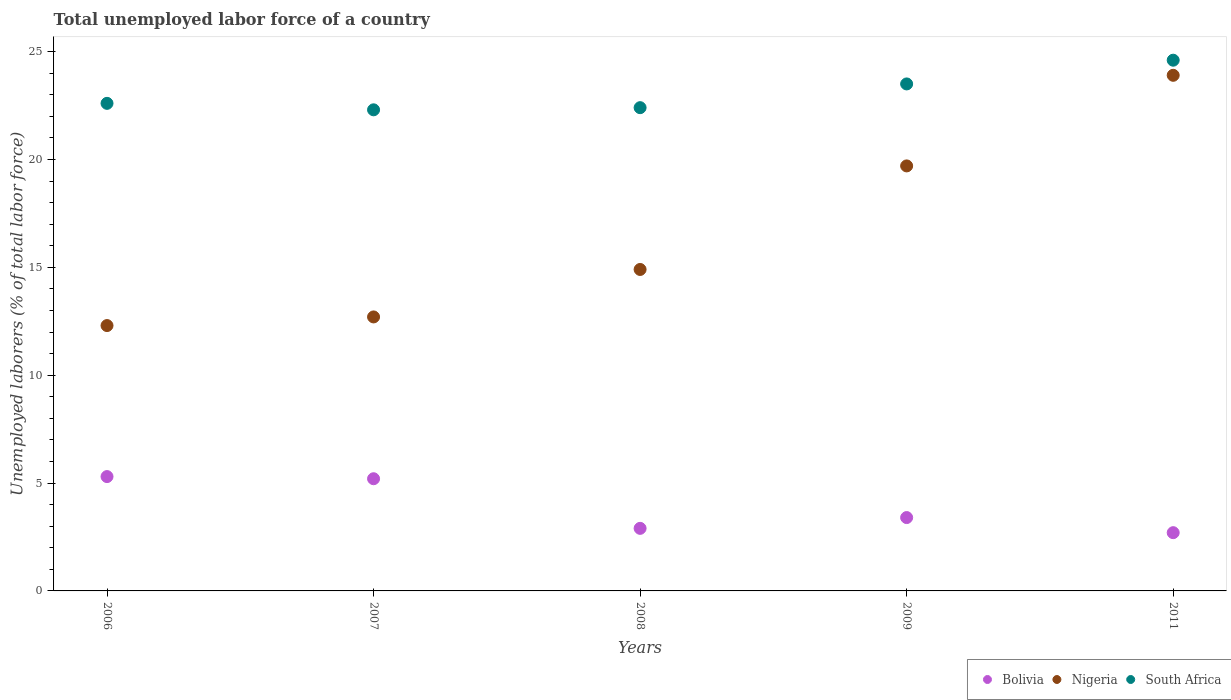What is the total unemployed labor force in Nigeria in 2009?
Offer a terse response. 19.7. Across all years, what is the maximum total unemployed labor force in South Africa?
Offer a very short reply. 24.6. Across all years, what is the minimum total unemployed labor force in Bolivia?
Provide a succinct answer. 2.7. In which year was the total unemployed labor force in Nigeria minimum?
Provide a short and direct response. 2006. What is the total total unemployed labor force in Bolivia in the graph?
Keep it short and to the point. 19.5. What is the difference between the total unemployed labor force in Nigeria in 2007 and that in 2008?
Give a very brief answer. -2.2. What is the difference between the total unemployed labor force in Bolivia in 2008 and the total unemployed labor force in Nigeria in 2009?
Your response must be concise. -16.8. What is the average total unemployed labor force in Nigeria per year?
Give a very brief answer. 16.7. In the year 2011, what is the difference between the total unemployed labor force in South Africa and total unemployed labor force in Nigeria?
Your answer should be compact. 0.7. In how many years, is the total unemployed labor force in Nigeria greater than 7 %?
Keep it short and to the point. 5. What is the ratio of the total unemployed labor force in Nigeria in 2008 to that in 2011?
Offer a very short reply. 0.62. Is the total unemployed labor force in Bolivia in 2006 less than that in 2007?
Your answer should be very brief. No. Is the difference between the total unemployed labor force in South Africa in 2007 and 2008 greater than the difference between the total unemployed labor force in Nigeria in 2007 and 2008?
Give a very brief answer. Yes. What is the difference between the highest and the second highest total unemployed labor force in South Africa?
Keep it short and to the point. 1.1. What is the difference between the highest and the lowest total unemployed labor force in Bolivia?
Keep it short and to the point. 2.6. Is the sum of the total unemployed labor force in South Africa in 2007 and 2011 greater than the maximum total unemployed labor force in Bolivia across all years?
Give a very brief answer. Yes. Does the total unemployed labor force in South Africa monotonically increase over the years?
Give a very brief answer. No. How many years are there in the graph?
Give a very brief answer. 5. What is the difference between two consecutive major ticks on the Y-axis?
Offer a very short reply. 5. Are the values on the major ticks of Y-axis written in scientific E-notation?
Offer a terse response. No. Does the graph contain grids?
Your response must be concise. No. Where does the legend appear in the graph?
Provide a succinct answer. Bottom right. What is the title of the graph?
Keep it short and to the point. Total unemployed labor force of a country. Does "Jamaica" appear as one of the legend labels in the graph?
Your response must be concise. No. What is the label or title of the X-axis?
Give a very brief answer. Years. What is the label or title of the Y-axis?
Provide a succinct answer. Unemployed laborers (% of total labor force). What is the Unemployed laborers (% of total labor force) of Bolivia in 2006?
Make the answer very short. 5.3. What is the Unemployed laborers (% of total labor force) in Nigeria in 2006?
Keep it short and to the point. 12.3. What is the Unemployed laborers (% of total labor force) of South Africa in 2006?
Offer a terse response. 22.6. What is the Unemployed laborers (% of total labor force) in Bolivia in 2007?
Offer a very short reply. 5.2. What is the Unemployed laborers (% of total labor force) in Nigeria in 2007?
Make the answer very short. 12.7. What is the Unemployed laborers (% of total labor force) of South Africa in 2007?
Make the answer very short. 22.3. What is the Unemployed laborers (% of total labor force) in Bolivia in 2008?
Make the answer very short. 2.9. What is the Unemployed laborers (% of total labor force) in Nigeria in 2008?
Your answer should be compact. 14.9. What is the Unemployed laborers (% of total labor force) in South Africa in 2008?
Make the answer very short. 22.4. What is the Unemployed laborers (% of total labor force) of Bolivia in 2009?
Keep it short and to the point. 3.4. What is the Unemployed laborers (% of total labor force) of Nigeria in 2009?
Keep it short and to the point. 19.7. What is the Unemployed laborers (% of total labor force) in South Africa in 2009?
Give a very brief answer. 23.5. What is the Unemployed laborers (% of total labor force) of Bolivia in 2011?
Offer a terse response. 2.7. What is the Unemployed laborers (% of total labor force) in Nigeria in 2011?
Give a very brief answer. 23.9. What is the Unemployed laborers (% of total labor force) in South Africa in 2011?
Your response must be concise. 24.6. Across all years, what is the maximum Unemployed laborers (% of total labor force) of Bolivia?
Offer a very short reply. 5.3. Across all years, what is the maximum Unemployed laborers (% of total labor force) of Nigeria?
Keep it short and to the point. 23.9. Across all years, what is the maximum Unemployed laborers (% of total labor force) of South Africa?
Keep it short and to the point. 24.6. Across all years, what is the minimum Unemployed laborers (% of total labor force) of Bolivia?
Provide a short and direct response. 2.7. Across all years, what is the minimum Unemployed laborers (% of total labor force) of Nigeria?
Keep it short and to the point. 12.3. Across all years, what is the minimum Unemployed laborers (% of total labor force) in South Africa?
Your answer should be compact. 22.3. What is the total Unemployed laborers (% of total labor force) of Bolivia in the graph?
Offer a terse response. 19.5. What is the total Unemployed laborers (% of total labor force) of Nigeria in the graph?
Offer a very short reply. 83.5. What is the total Unemployed laborers (% of total labor force) of South Africa in the graph?
Make the answer very short. 115.4. What is the difference between the Unemployed laborers (% of total labor force) in Nigeria in 2006 and that in 2007?
Make the answer very short. -0.4. What is the difference between the Unemployed laborers (% of total labor force) of Bolivia in 2006 and that in 2008?
Provide a succinct answer. 2.4. What is the difference between the Unemployed laborers (% of total labor force) of Nigeria in 2006 and that in 2008?
Offer a terse response. -2.6. What is the difference between the Unemployed laborers (% of total labor force) in Bolivia in 2006 and that in 2009?
Ensure brevity in your answer.  1.9. What is the difference between the Unemployed laborers (% of total labor force) of Nigeria in 2006 and that in 2009?
Ensure brevity in your answer.  -7.4. What is the difference between the Unemployed laborers (% of total labor force) of Bolivia in 2007 and that in 2008?
Your answer should be very brief. 2.3. What is the difference between the Unemployed laborers (% of total labor force) of Bolivia in 2007 and that in 2009?
Your answer should be compact. 1.8. What is the difference between the Unemployed laborers (% of total labor force) in Nigeria in 2007 and that in 2011?
Your response must be concise. -11.2. What is the difference between the Unemployed laborers (% of total labor force) of Bolivia in 2008 and that in 2009?
Your response must be concise. -0.5. What is the difference between the Unemployed laborers (% of total labor force) of Nigeria in 2008 and that in 2009?
Give a very brief answer. -4.8. What is the difference between the Unemployed laborers (% of total labor force) in Bolivia in 2008 and that in 2011?
Make the answer very short. 0.2. What is the difference between the Unemployed laborers (% of total labor force) of Nigeria in 2008 and that in 2011?
Your answer should be very brief. -9. What is the difference between the Unemployed laborers (% of total labor force) of Bolivia in 2009 and that in 2011?
Make the answer very short. 0.7. What is the difference between the Unemployed laborers (% of total labor force) of South Africa in 2009 and that in 2011?
Provide a short and direct response. -1.1. What is the difference between the Unemployed laborers (% of total labor force) of Nigeria in 2006 and the Unemployed laborers (% of total labor force) of South Africa in 2007?
Make the answer very short. -10. What is the difference between the Unemployed laborers (% of total labor force) in Bolivia in 2006 and the Unemployed laborers (% of total labor force) in Nigeria in 2008?
Your response must be concise. -9.6. What is the difference between the Unemployed laborers (% of total labor force) in Bolivia in 2006 and the Unemployed laborers (% of total labor force) in South Africa in 2008?
Offer a very short reply. -17.1. What is the difference between the Unemployed laborers (% of total labor force) in Nigeria in 2006 and the Unemployed laborers (% of total labor force) in South Africa in 2008?
Offer a terse response. -10.1. What is the difference between the Unemployed laborers (% of total labor force) of Bolivia in 2006 and the Unemployed laborers (% of total labor force) of Nigeria in 2009?
Make the answer very short. -14.4. What is the difference between the Unemployed laborers (% of total labor force) of Bolivia in 2006 and the Unemployed laborers (% of total labor force) of South Africa in 2009?
Make the answer very short. -18.2. What is the difference between the Unemployed laborers (% of total labor force) in Bolivia in 2006 and the Unemployed laborers (% of total labor force) in Nigeria in 2011?
Your answer should be very brief. -18.6. What is the difference between the Unemployed laborers (% of total labor force) in Bolivia in 2006 and the Unemployed laborers (% of total labor force) in South Africa in 2011?
Your response must be concise. -19.3. What is the difference between the Unemployed laborers (% of total labor force) in Nigeria in 2006 and the Unemployed laborers (% of total labor force) in South Africa in 2011?
Offer a terse response. -12.3. What is the difference between the Unemployed laborers (% of total labor force) of Bolivia in 2007 and the Unemployed laborers (% of total labor force) of South Africa in 2008?
Provide a succinct answer. -17.2. What is the difference between the Unemployed laborers (% of total labor force) in Nigeria in 2007 and the Unemployed laborers (% of total labor force) in South Africa in 2008?
Provide a succinct answer. -9.7. What is the difference between the Unemployed laborers (% of total labor force) in Bolivia in 2007 and the Unemployed laborers (% of total labor force) in South Africa in 2009?
Offer a terse response. -18.3. What is the difference between the Unemployed laborers (% of total labor force) of Nigeria in 2007 and the Unemployed laborers (% of total labor force) of South Africa in 2009?
Give a very brief answer. -10.8. What is the difference between the Unemployed laborers (% of total labor force) of Bolivia in 2007 and the Unemployed laborers (% of total labor force) of Nigeria in 2011?
Provide a succinct answer. -18.7. What is the difference between the Unemployed laborers (% of total labor force) of Bolivia in 2007 and the Unemployed laborers (% of total labor force) of South Africa in 2011?
Offer a terse response. -19.4. What is the difference between the Unemployed laborers (% of total labor force) in Nigeria in 2007 and the Unemployed laborers (% of total labor force) in South Africa in 2011?
Provide a short and direct response. -11.9. What is the difference between the Unemployed laborers (% of total labor force) in Bolivia in 2008 and the Unemployed laborers (% of total labor force) in Nigeria in 2009?
Ensure brevity in your answer.  -16.8. What is the difference between the Unemployed laborers (% of total labor force) of Bolivia in 2008 and the Unemployed laborers (% of total labor force) of South Africa in 2009?
Offer a very short reply. -20.6. What is the difference between the Unemployed laborers (% of total labor force) in Bolivia in 2008 and the Unemployed laborers (% of total labor force) in South Africa in 2011?
Your answer should be compact. -21.7. What is the difference between the Unemployed laborers (% of total labor force) of Nigeria in 2008 and the Unemployed laborers (% of total labor force) of South Africa in 2011?
Your answer should be very brief. -9.7. What is the difference between the Unemployed laborers (% of total labor force) of Bolivia in 2009 and the Unemployed laborers (% of total labor force) of Nigeria in 2011?
Your answer should be compact. -20.5. What is the difference between the Unemployed laborers (% of total labor force) of Bolivia in 2009 and the Unemployed laborers (% of total labor force) of South Africa in 2011?
Your answer should be very brief. -21.2. What is the difference between the Unemployed laborers (% of total labor force) in Nigeria in 2009 and the Unemployed laborers (% of total labor force) in South Africa in 2011?
Offer a terse response. -4.9. What is the average Unemployed laborers (% of total labor force) in South Africa per year?
Offer a terse response. 23.08. In the year 2006, what is the difference between the Unemployed laborers (% of total labor force) of Bolivia and Unemployed laborers (% of total labor force) of South Africa?
Your answer should be compact. -17.3. In the year 2006, what is the difference between the Unemployed laborers (% of total labor force) of Nigeria and Unemployed laborers (% of total labor force) of South Africa?
Ensure brevity in your answer.  -10.3. In the year 2007, what is the difference between the Unemployed laborers (% of total labor force) in Bolivia and Unemployed laborers (% of total labor force) in Nigeria?
Offer a very short reply. -7.5. In the year 2007, what is the difference between the Unemployed laborers (% of total labor force) in Bolivia and Unemployed laborers (% of total labor force) in South Africa?
Ensure brevity in your answer.  -17.1. In the year 2007, what is the difference between the Unemployed laborers (% of total labor force) of Nigeria and Unemployed laborers (% of total labor force) of South Africa?
Your response must be concise. -9.6. In the year 2008, what is the difference between the Unemployed laborers (% of total labor force) of Bolivia and Unemployed laborers (% of total labor force) of Nigeria?
Your answer should be very brief. -12. In the year 2008, what is the difference between the Unemployed laborers (% of total labor force) in Bolivia and Unemployed laborers (% of total labor force) in South Africa?
Offer a terse response. -19.5. In the year 2008, what is the difference between the Unemployed laborers (% of total labor force) of Nigeria and Unemployed laborers (% of total labor force) of South Africa?
Provide a succinct answer. -7.5. In the year 2009, what is the difference between the Unemployed laborers (% of total labor force) in Bolivia and Unemployed laborers (% of total labor force) in Nigeria?
Make the answer very short. -16.3. In the year 2009, what is the difference between the Unemployed laborers (% of total labor force) of Bolivia and Unemployed laborers (% of total labor force) of South Africa?
Give a very brief answer. -20.1. In the year 2009, what is the difference between the Unemployed laborers (% of total labor force) of Nigeria and Unemployed laborers (% of total labor force) of South Africa?
Give a very brief answer. -3.8. In the year 2011, what is the difference between the Unemployed laborers (% of total labor force) of Bolivia and Unemployed laborers (% of total labor force) of Nigeria?
Offer a terse response. -21.2. In the year 2011, what is the difference between the Unemployed laborers (% of total labor force) of Bolivia and Unemployed laborers (% of total labor force) of South Africa?
Give a very brief answer. -21.9. In the year 2011, what is the difference between the Unemployed laborers (% of total labor force) of Nigeria and Unemployed laborers (% of total labor force) of South Africa?
Offer a terse response. -0.7. What is the ratio of the Unemployed laborers (% of total labor force) in Bolivia in 2006 to that in 2007?
Your answer should be compact. 1.02. What is the ratio of the Unemployed laborers (% of total labor force) in Nigeria in 2006 to that in 2007?
Give a very brief answer. 0.97. What is the ratio of the Unemployed laborers (% of total labor force) of South Africa in 2006 to that in 2007?
Offer a terse response. 1.01. What is the ratio of the Unemployed laborers (% of total labor force) in Bolivia in 2006 to that in 2008?
Your response must be concise. 1.83. What is the ratio of the Unemployed laborers (% of total labor force) in Nigeria in 2006 to that in 2008?
Give a very brief answer. 0.83. What is the ratio of the Unemployed laborers (% of total labor force) of South Africa in 2006 to that in 2008?
Offer a terse response. 1.01. What is the ratio of the Unemployed laborers (% of total labor force) in Bolivia in 2006 to that in 2009?
Your response must be concise. 1.56. What is the ratio of the Unemployed laborers (% of total labor force) of Nigeria in 2006 to that in 2009?
Make the answer very short. 0.62. What is the ratio of the Unemployed laborers (% of total labor force) in South Africa in 2006 to that in 2009?
Ensure brevity in your answer.  0.96. What is the ratio of the Unemployed laborers (% of total labor force) of Bolivia in 2006 to that in 2011?
Your response must be concise. 1.96. What is the ratio of the Unemployed laborers (% of total labor force) of Nigeria in 2006 to that in 2011?
Your response must be concise. 0.51. What is the ratio of the Unemployed laborers (% of total labor force) in South Africa in 2006 to that in 2011?
Offer a very short reply. 0.92. What is the ratio of the Unemployed laborers (% of total labor force) of Bolivia in 2007 to that in 2008?
Your answer should be very brief. 1.79. What is the ratio of the Unemployed laborers (% of total labor force) of Nigeria in 2007 to that in 2008?
Provide a succinct answer. 0.85. What is the ratio of the Unemployed laborers (% of total labor force) in South Africa in 2007 to that in 2008?
Offer a terse response. 1. What is the ratio of the Unemployed laborers (% of total labor force) in Bolivia in 2007 to that in 2009?
Keep it short and to the point. 1.53. What is the ratio of the Unemployed laborers (% of total labor force) in Nigeria in 2007 to that in 2009?
Your answer should be compact. 0.64. What is the ratio of the Unemployed laborers (% of total labor force) of South Africa in 2007 to that in 2009?
Keep it short and to the point. 0.95. What is the ratio of the Unemployed laborers (% of total labor force) in Bolivia in 2007 to that in 2011?
Ensure brevity in your answer.  1.93. What is the ratio of the Unemployed laborers (% of total labor force) of Nigeria in 2007 to that in 2011?
Provide a short and direct response. 0.53. What is the ratio of the Unemployed laborers (% of total labor force) in South Africa in 2007 to that in 2011?
Ensure brevity in your answer.  0.91. What is the ratio of the Unemployed laborers (% of total labor force) of Bolivia in 2008 to that in 2009?
Ensure brevity in your answer.  0.85. What is the ratio of the Unemployed laborers (% of total labor force) of Nigeria in 2008 to that in 2009?
Keep it short and to the point. 0.76. What is the ratio of the Unemployed laborers (% of total labor force) in South Africa in 2008 to that in 2009?
Give a very brief answer. 0.95. What is the ratio of the Unemployed laborers (% of total labor force) in Bolivia in 2008 to that in 2011?
Your answer should be compact. 1.07. What is the ratio of the Unemployed laborers (% of total labor force) in Nigeria in 2008 to that in 2011?
Your answer should be very brief. 0.62. What is the ratio of the Unemployed laborers (% of total labor force) in South Africa in 2008 to that in 2011?
Make the answer very short. 0.91. What is the ratio of the Unemployed laborers (% of total labor force) in Bolivia in 2009 to that in 2011?
Provide a short and direct response. 1.26. What is the ratio of the Unemployed laborers (% of total labor force) of Nigeria in 2009 to that in 2011?
Provide a succinct answer. 0.82. What is the ratio of the Unemployed laborers (% of total labor force) of South Africa in 2009 to that in 2011?
Provide a succinct answer. 0.96. 